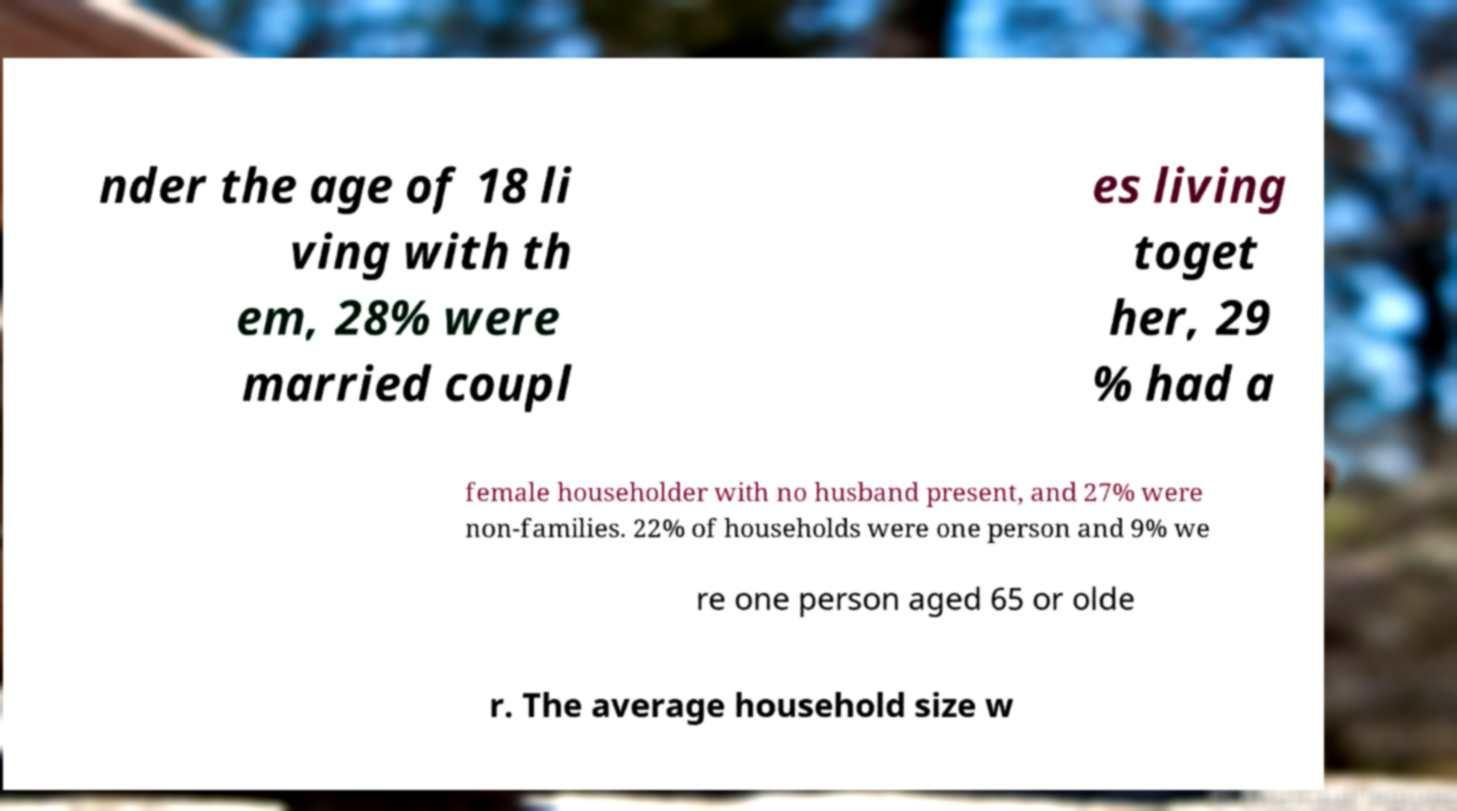Could you assist in decoding the text presented in this image and type it out clearly? nder the age of 18 li ving with th em, 28% were married coupl es living toget her, 29 % had a female householder with no husband present, and 27% were non-families. 22% of households were one person and 9% we re one person aged 65 or olde r. The average household size w 